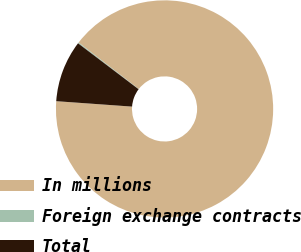Convert chart. <chart><loc_0><loc_0><loc_500><loc_500><pie_chart><fcel>In millions<fcel>Foreign exchange contracts<fcel>Total<nl><fcel>90.68%<fcel>0.14%<fcel>9.19%<nl></chart> 